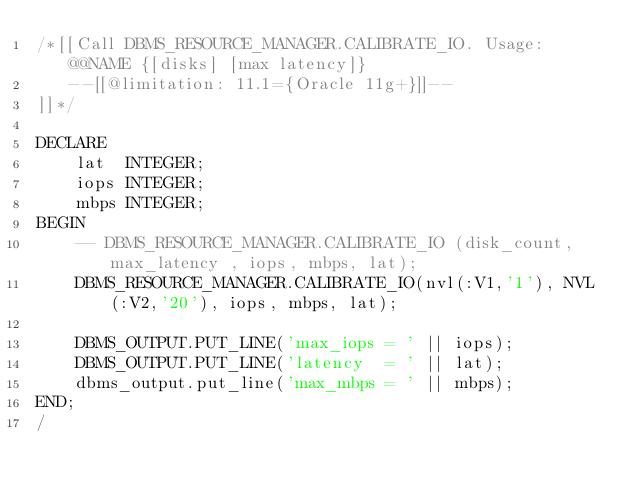Convert code to text. <code><loc_0><loc_0><loc_500><loc_500><_SQL_>/*[[Call DBMS_RESOURCE_MANAGER.CALIBRATE_IO. Usage: @@NAME {[disks] [max latency]}
   --[[@limitation: 11.1={Oracle 11g+}]]--
]]*/

DECLARE
    lat  INTEGER;
    iops INTEGER;
    mbps INTEGER;
BEGIN
    -- DBMS_RESOURCE_MANAGER.CALIBRATE_IO (disk_count,max_latency , iops, mbps, lat);
    DBMS_RESOURCE_MANAGER.CALIBRATE_IO(nvl(:V1,'1'), NVL(:V2,'20'), iops, mbps, lat);

    DBMS_OUTPUT.PUT_LINE('max_iops = ' || iops);
    DBMS_OUTPUT.PUT_LINE('latency  = ' || lat);
    dbms_output.put_line('max_mbps = ' || mbps);
END;
/</code> 